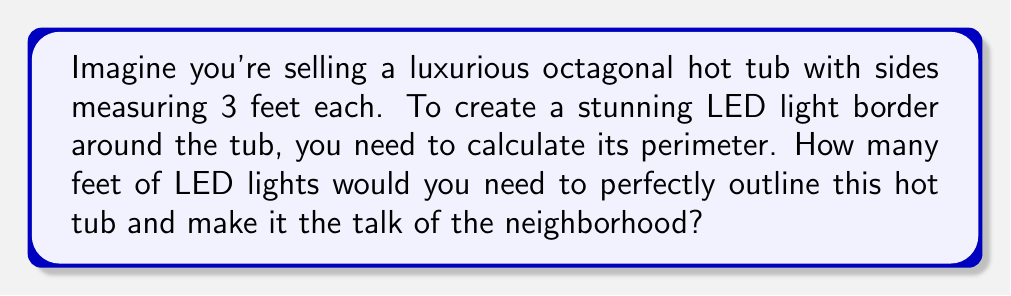Solve this math problem. Let's approach this step-by-step:

1) First, recall that a regular octagon has 8 equal sides.

2) We're given that each side measures 3 feet.

3) To calculate the perimeter, we need to add up the lengths of all sides.

4) Since all sides are equal, we can multiply the length of one side by the number of sides:

   $$\text{Perimeter} = \text{Number of sides} \times \text{Length of one side}$$
   $$\text{Perimeter} = 8 \times 3$$
   $$\text{Perimeter} = 24\text{ feet}$$

5) Therefore, you would need 24 feet of LED lights to outline the entire hot tub.

[asy]
unitsize(20);
pair A,B,C,D,E,F,G,H;
A = (1,0);
B = (1+sqrt(2)/2, sqrt(2)/2);
C = (1+sqrt(2), 1);
D = (2+sqrt(2), 1+sqrt(2)/2);
E = (2+sqrt(2), 1+sqrt(2));
F = (1+sqrt(2), 2+sqrt(2));
G = (1, 1+sqrt(2));
H = (0, 1);
draw(A--B--C--D--E--F--G--H--cycle);
label("3 ft", (A+B)/2, SE);
[/asy]
Answer: 24 feet 